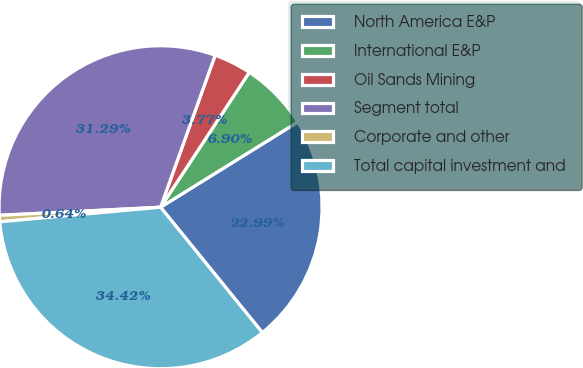Convert chart to OTSL. <chart><loc_0><loc_0><loc_500><loc_500><pie_chart><fcel>North America E&P<fcel>International E&P<fcel>Oil Sands Mining<fcel>Segment total<fcel>Corporate and other<fcel>Total capital investment and<nl><fcel>22.99%<fcel>6.9%<fcel>3.77%<fcel>31.29%<fcel>0.64%<fcel>34.42%<nl></chart> 